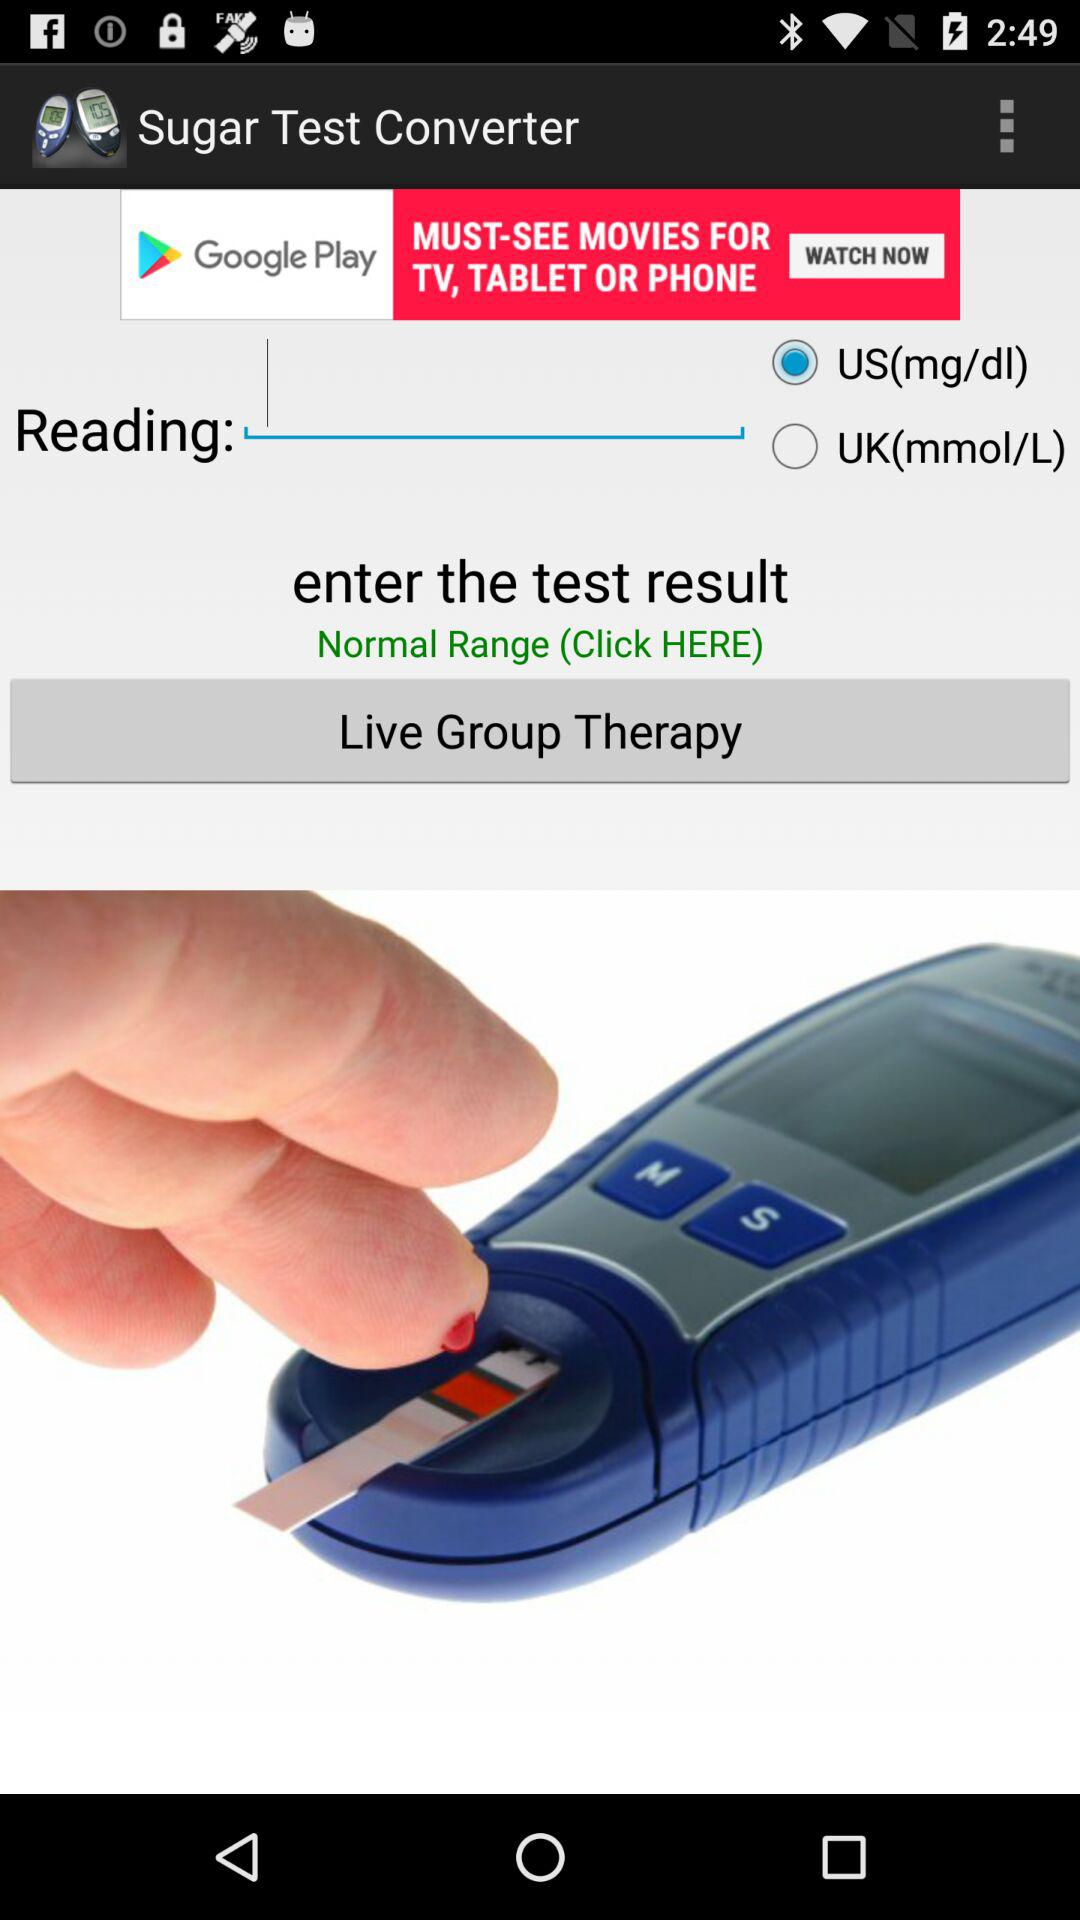What is the reading of the blood sugar?
When the provided information is insufficient, respond with <no answer>. <no answer> 